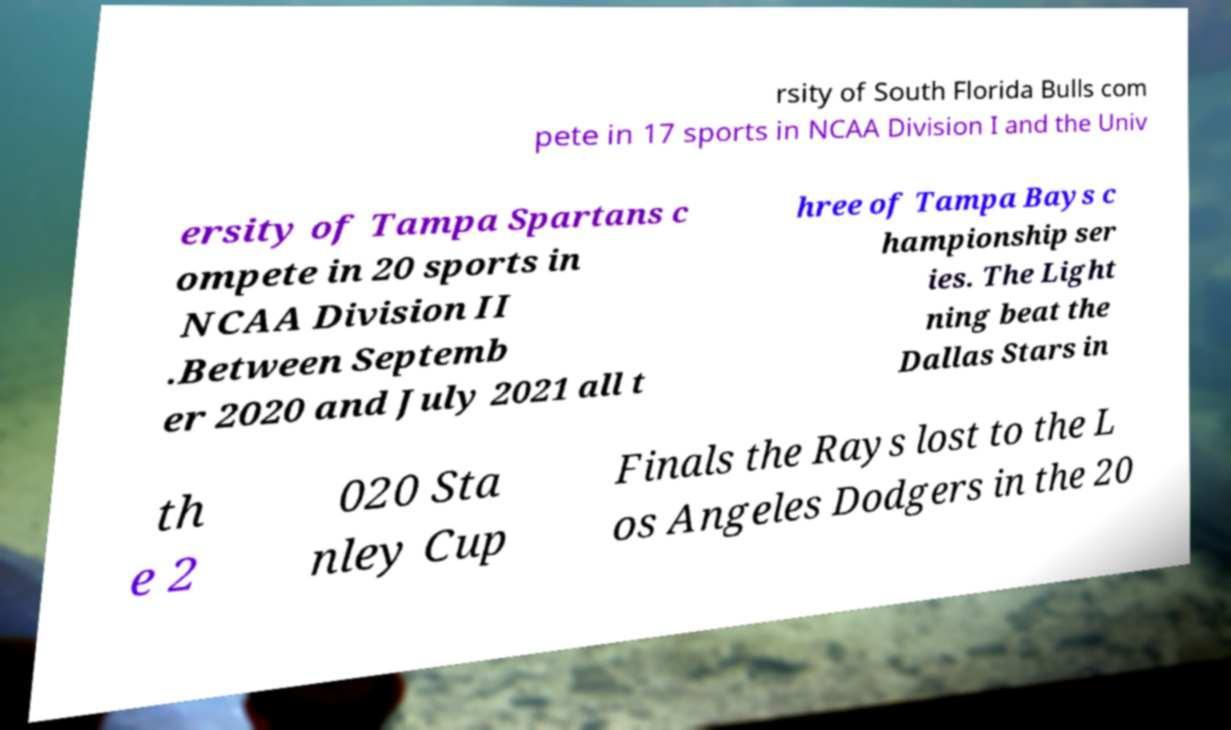Could you extract and type out the text from this image? rsity of South Florida Bulls com pete in 17 sports in NCAA Division I and the Univ ersity of Tampa Spartans c ompete in 20 sports in NCAA Division II .Between Septemb er 2020 and July 2021 all t hree of Tampa Bays c hampionship ser ies. The Light ning beat the Dallas Stars in th e 2 020 Sta nley Cup Finals the Rays lost to the L os Angeles Dodgers in the 20 